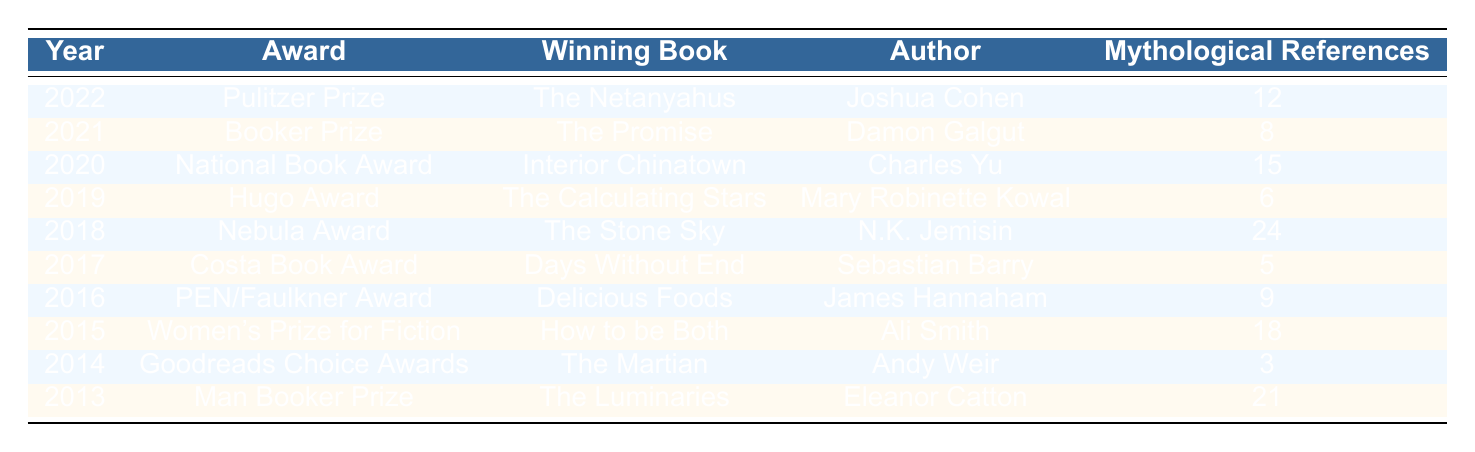What is the winning book of the Pulitzer Prize in 2022? The table shows that the winning book of the Pulitzer Prize in 2022 is "The Netanyahus."
Answer: The Netanyahus Which author won the Booker Prize in 2021? Looking at the table, the author who won the Booker Prize in 2021 is Damon Galgut.
Answer: Damon Galgut What is the total number of mythological references in the winning books from 2018 and 2020? From the table, in 2018, "The Stone Sky" had 24 mythological references and in 2020, "Interior Chinatown" had 15. The total is 24 + 15 = 39.
Answer: 39 Which award-winning book contains the most mythological references, and how many are there? According to the table, "The Stone Sky" won the Nebula Award in 2018 with the highest count of mythological references, totaling 24.
Answer: The Stone Sky, 24 Did "The Martian" have more mythological references than "Days Without End"? The table indicates "The Martian" has 3 mythological references, while "Days Without End" has 5. Therefore, "The Martian" did not have more mythological references than "Days Without End."
Answer: No What is the average number of mythological references for the winning books awarded between 2016 and 2021? The books awarded between 2016 and 2021 and their references are: 9 (2016), 18 (2015), 5 (2017), 24 (2018), 8 (2021). Summing these, we get 9 + 18 + 5 + 24 + 8 = 64. There are 5 data points, so the average is 64 / 5 = 12.8.
Answer: 12.8 Which author has the least mythological references in the award-winning books listed? Based on the table, Sebastian Barry's book "Days Without End" has the least mythological references with a count of 5.
Answer: Sebastian Barry What year had the highest number of mythological references, and what was that number? Reviewing the table, the year 2018 had the highest number of mythological references, which was 24 for "The Stone Sky."
Answer: 2018, 24 How many winning books had more than 10 mythological references? From the data, "The Netanyahus" (12), "Interior Chinatown" (15), "The Stone Sky" (24), and "How to be Both" (18) all had more than 10 references, totaling 4 books.
Answer: 4 